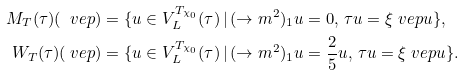<formula> <loc_0><loc_0><loc_500><loc_500>M _ { T } ( \tau ) ( \ v e p ) & = \{ u \in V _ { L } ^ { T _ { \chi _ { 0 } } } ( \tau ) \, | \, ( \to m ^ { 2 } ) _ { 1 } u = 0 , \, \tau u = \xi ^ { \ } v e p u \} , \\ W _ { T } ( \tau ) ( \ v e p ) & = \{ u \in V _ { L } ^ { T _ { \chi _ { 0 } } } ( \tau ) \, | \, ( \to m ^ { 2 } ) _ { 1 } u = \frac { 2 } { 5 } u , \, \tau u = \xi ^ { \ } v e p u \} .</formula> 